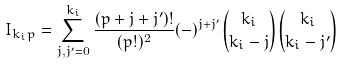Convert formula to latex. <formula><loc_0><loc_0><loc_500><loc_500>I _ { k _ { i } p } = \sum _ { j , j ^ { \prime } = 0 } ^ { k _ { i } } \frac { ( p + j + j ^ { \prime } ) ! } { ( p ! ) ^ { 2 } } ( - ) ^ { j + j ^ { \prime } } { k _ { i } \choose k _ { i } - j } { k _ { i } \choose k _ { i } - j ^ { \prime } }</formula> 